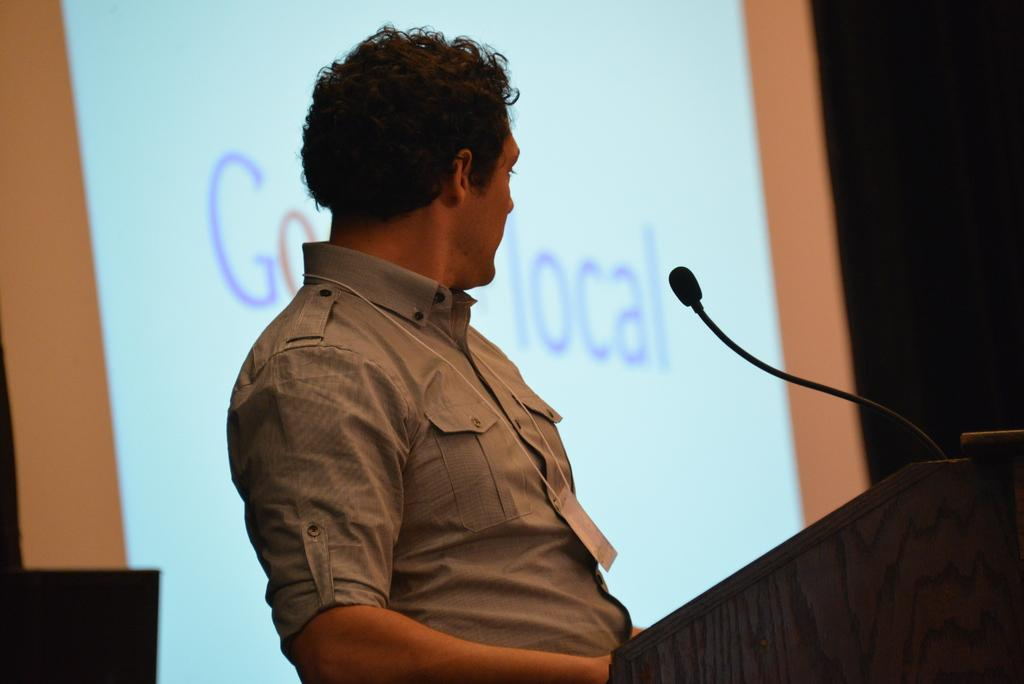What is the main subject of the image? There is a man standing in the image. What is the man wearing? The man is wearing clothes. What object can be seen near the man? There is a podium in the image. What device is present for amplifying sound? There is a microphone in the image. What is used for displaying visual information? There is a projected screen in the image. What type of decision can be seen on the projected screen? There is no decision visible on the projected screen in the image; it is not mentioned in the provided facts. 